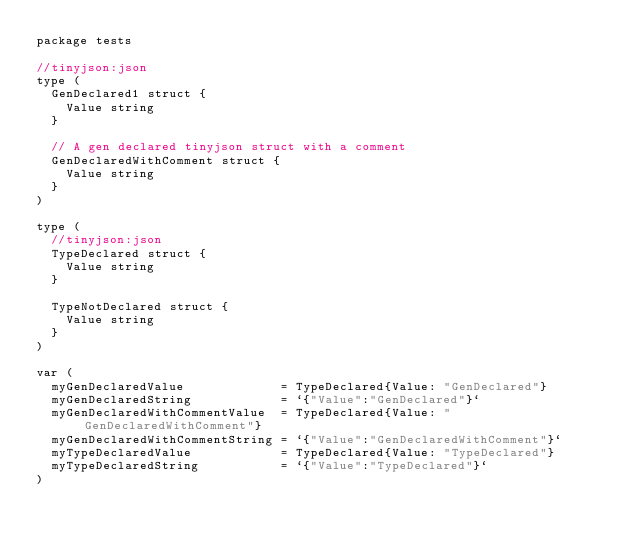Convert code to text. <code><loc_0><loc_0><loc_500><loc_500><_Go_>package tests

//tinyjson:json
type (
	GenDeclared1 struct {
		Value string
	}

	// A gen declared tinyjson struct with a comment
	GenDeclaredWithComment struct {
		Value string
	}
)

type (
	//tinyjson:json
	TypeDeclared struct {
		Value string
	}

	TypeNotDeclared struct {
		Value string
	}
)

var (
	myGenDeclaredValue             = TypeDeclared{Value: "GenDeclared"}
	myGenDeclaredString            = `{"Value":"GenDeclared"}`
	myGenDeclaredWithCommentValue  = TypeDeclared{Value: "GenDeclaredWithComment"}
	myGenDeclaredWithCommentString = `{"Value":"GenDeclaredWithComment"}`
	myTypeDeclaredValue            = TypeDeclared{Value: "TypeDeclared"}
	myTypeDeclaredString           = `{"Value":"TypeDeclared"}`
)
</code> 